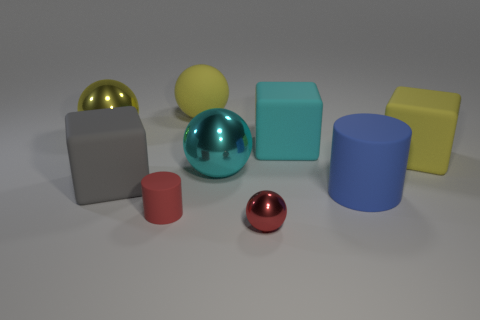What's the texture of the objects in the image? Although the exact texture cannot be felt through the image, visually the spheres, cylinder, and cube all seem to have smooth surfaces. Some exhibit a matte finish, while others have a more shiny or reflective finish. 